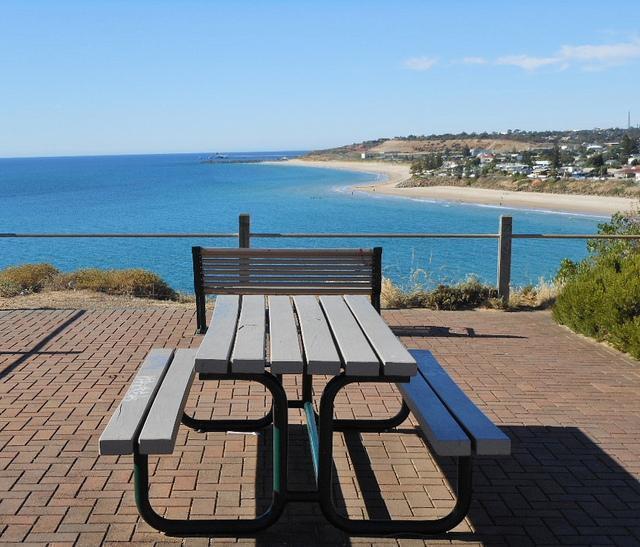What color is the top of the picnic bench painted all up like?
From the following set of four choices, select the accurate answer to respond to the question.
Options: Yellow, blue, red, gray. Gray. 